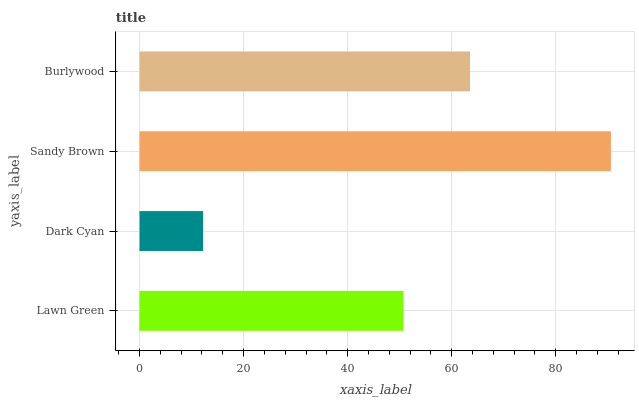Is Dark Cyan the minimum?
Answer yes or no. Yes. Is Sandy Brown the maximum?
Answer yes or no. Yes. Is Sandy Brown the minimum?
Answer yes or no. No. Is Dark Cyan the maximum?
Answer yes or no. No. Is Sandy Brown greater than Dark Cyan?
Answer yes or no. Yes. Is Dark Cyan less than Sandy Brown?
Answer yes or no. Yes. Is Dark Cyan greater than Sandy Brown?
Answer yes or no. No. Is Sandy Brown less than Dark Cyan?
Answer yes or no. No. Is Burlywood the high median?
Answer yes or no. Yes. Is Lawn Green the low median?
Answer yes or no. Yes. Is Dark Cyan the high median?
Answer yes or no. No. Is Dark Cyan the low median?
Answer yes or no. No. 